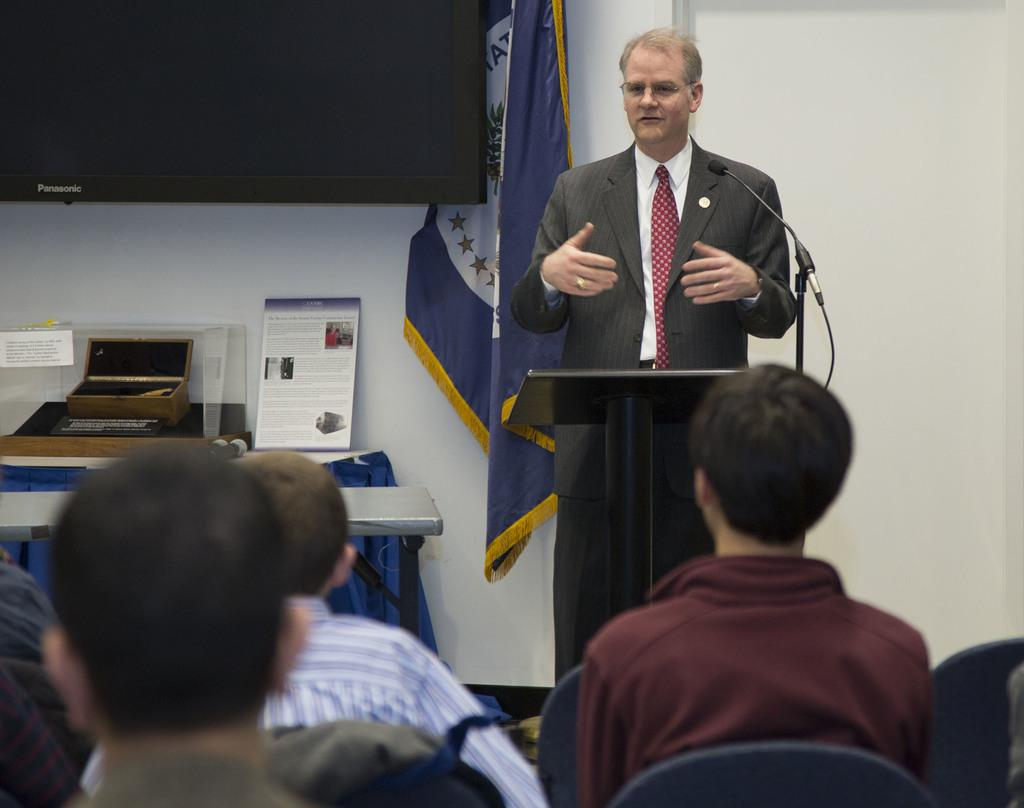What is the man in the image doing? The man is standing near a microphone. What is the man wearing in the image? The man is wearing a coat, tie, and shirt. What can be seen in the image besides the man? There are people sitting on chairs in the image. What type of impulse can be seen affecting the bear in the image? There is no bear present in the image, so it is not possible to determine any impulses affecting a bear. Is there any popcorn visible in the image? There is no popcorn present in the image. 